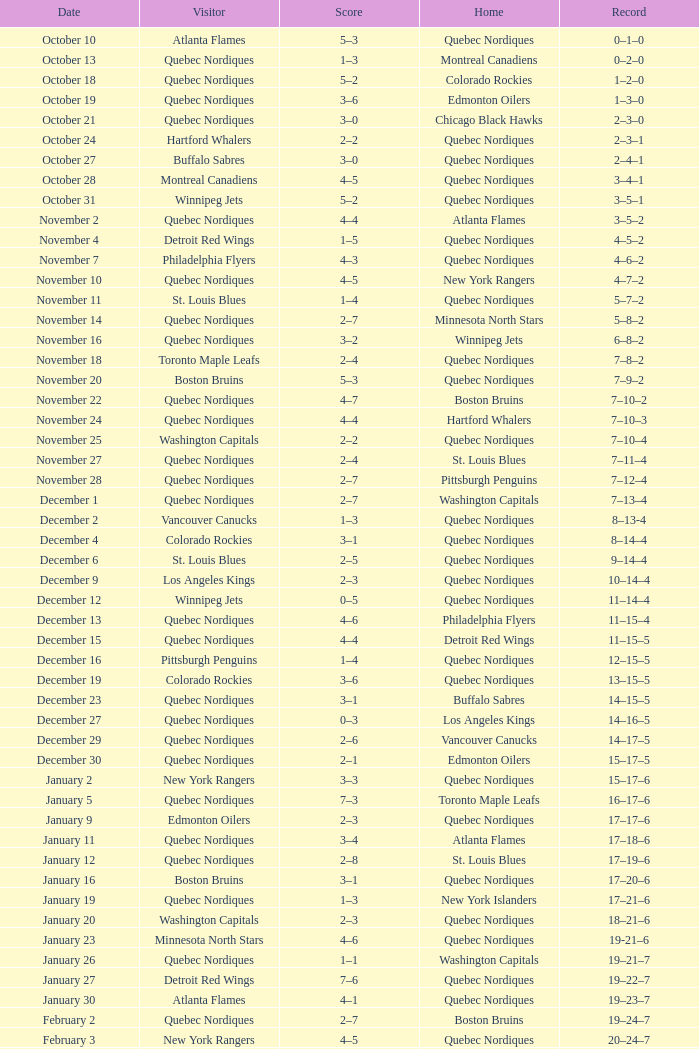Which house has a date of april 1st? Quebec Nordiques. 